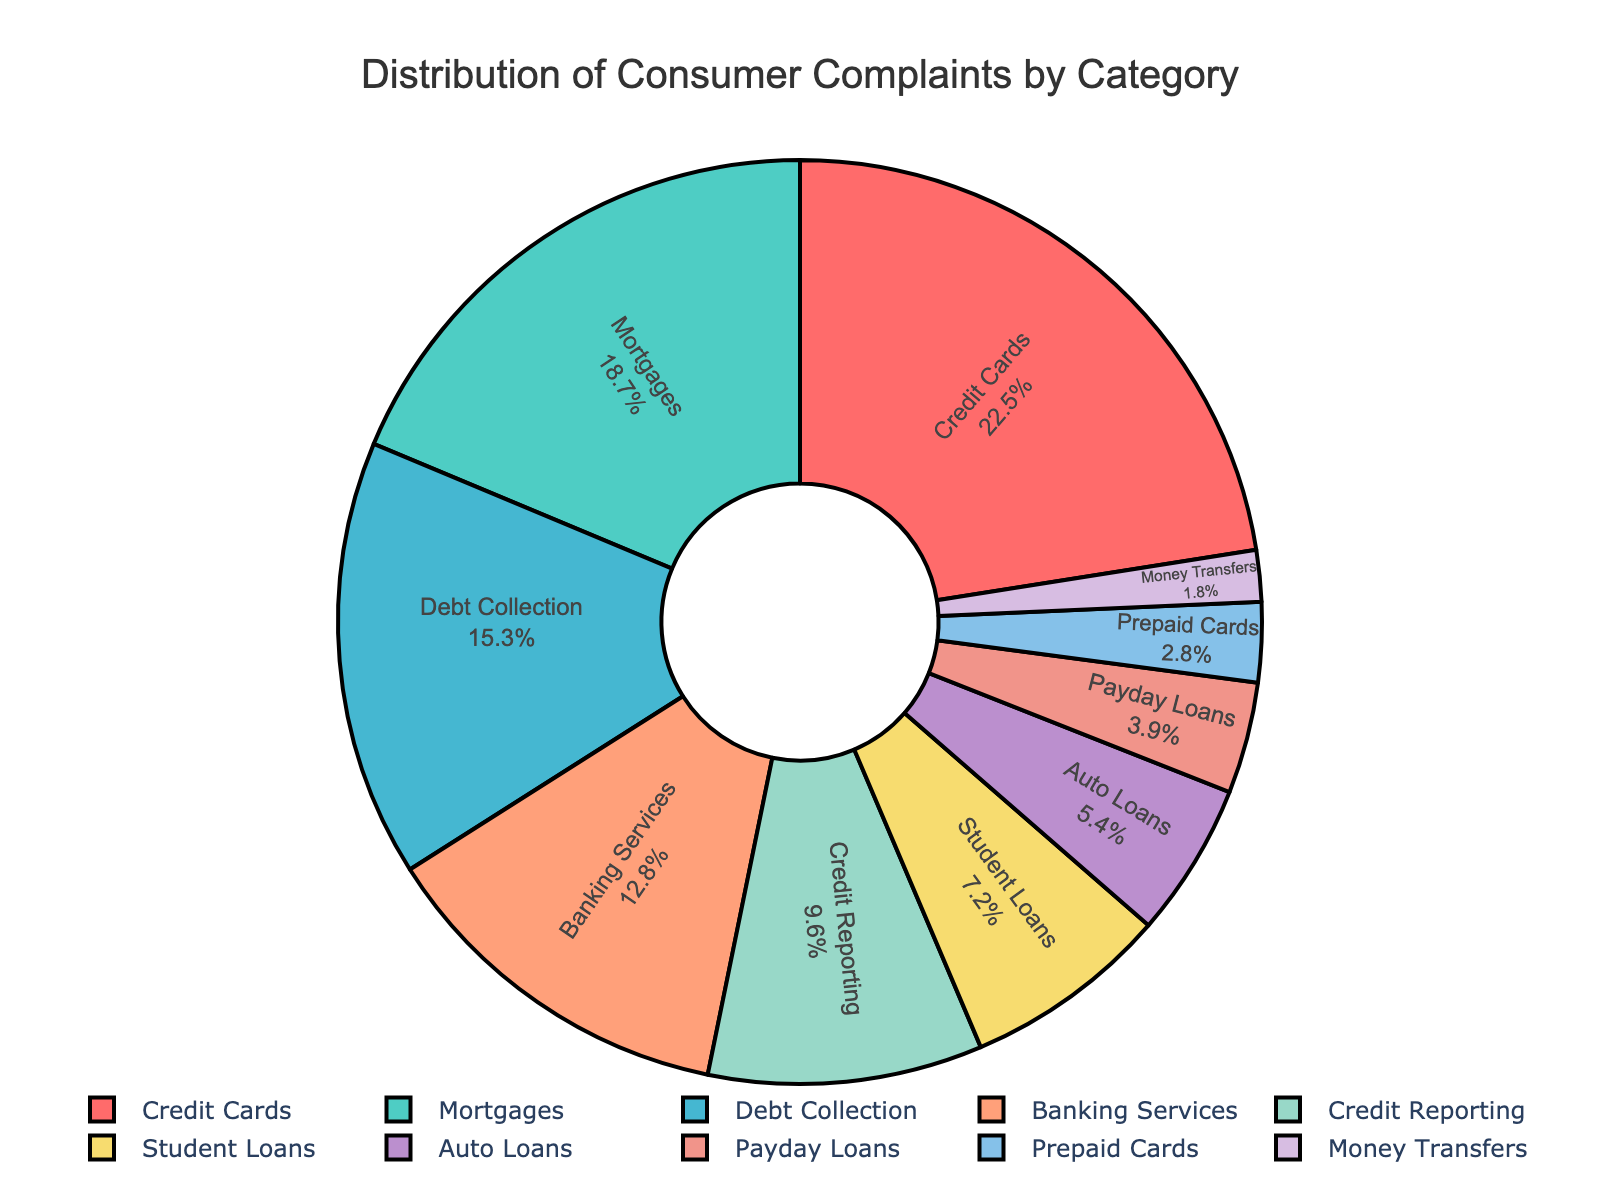What's the most common category of consumer complaints? The pie chart shows that the category with the highest percentage is "Credit Cards" at 22.5%.
Answer: Credit Cards Which category has fewer consumer complaints, Payday Loans or Auto Loans? According to the chart, Payday Loans have 3.9% of the complaints, whereas Auto Loans have 5.4%. Therefore, Payday Loans have fewer complaints.
Answer: Payday Loans What is the total percentage of complaints in the top three categories? The top three categories by percentage are Credit Cards (22.5%), Mortgages (18.7%), and Debt Collection (15.3%). Adding these together: 22.5 + 18.7 + 15.3 = 56.5%.
Answer: 56.5% How much higher is the percentage of complaints for Student Loans compared to Prepaid Cards? The chart shows Student Loans have 7.2% and Prepaid Cards have 2.8%. The difference is 7.2 - 2.8 = 4.4%.
Answer: 4.4% Which category has the lowest percentage of consumer complaints? The category "Money Transfers" has the lowest percentage at 1.8%.
Answer: Money Transfers If you combine the percentages of Banking Services and Credit Reporting, how does it compare to the percentage for Mortgages? Banking Services have 12.8% and Credit Reporting has 9.6%, totaling 12.8 + 9.6 = 22.4%. Mortgages alone have 18.7%. So, the combined percentage of Banking Services and Credit Reporting is higher than Mortgages.
Answer: Higher Are there more consumer complaints about Auto Loans or about Student Loans? The pie chart shows that Student Loans have 7.2% of the complaints and Auto Loans have 5.4%, so there are more complaints about Student Loans.
Answer: Student Loans What's the combined percentage of consumer complaints for categories under 10%? Categories under 10% are Credit Reporting (9.6%), Student Loans (7.2%), Auto Loans (5.4%), Payday Loans (3.9%), Prepaid Cards (2.8%), and Money Transfers (1.8%). Adding these percentages: 9.6 + 7.2 + 5.4 + 3.9 + 2.8 + 1.8 = 30.7%.
Answer: 30.7% What is the second most common category for consumer complaints and its percentage? The second most common category based on the chart is Mortgages with 18.7%.
Answer: Mortgages; 18.7% By how much do the complaints about Credit Cards exceed those of Banking Services? Credit Cards have 22.5% while Banking Services have 12.8%. The excess is 22.5 - 12.8 = 9.7%.
Answer: 9.7% 